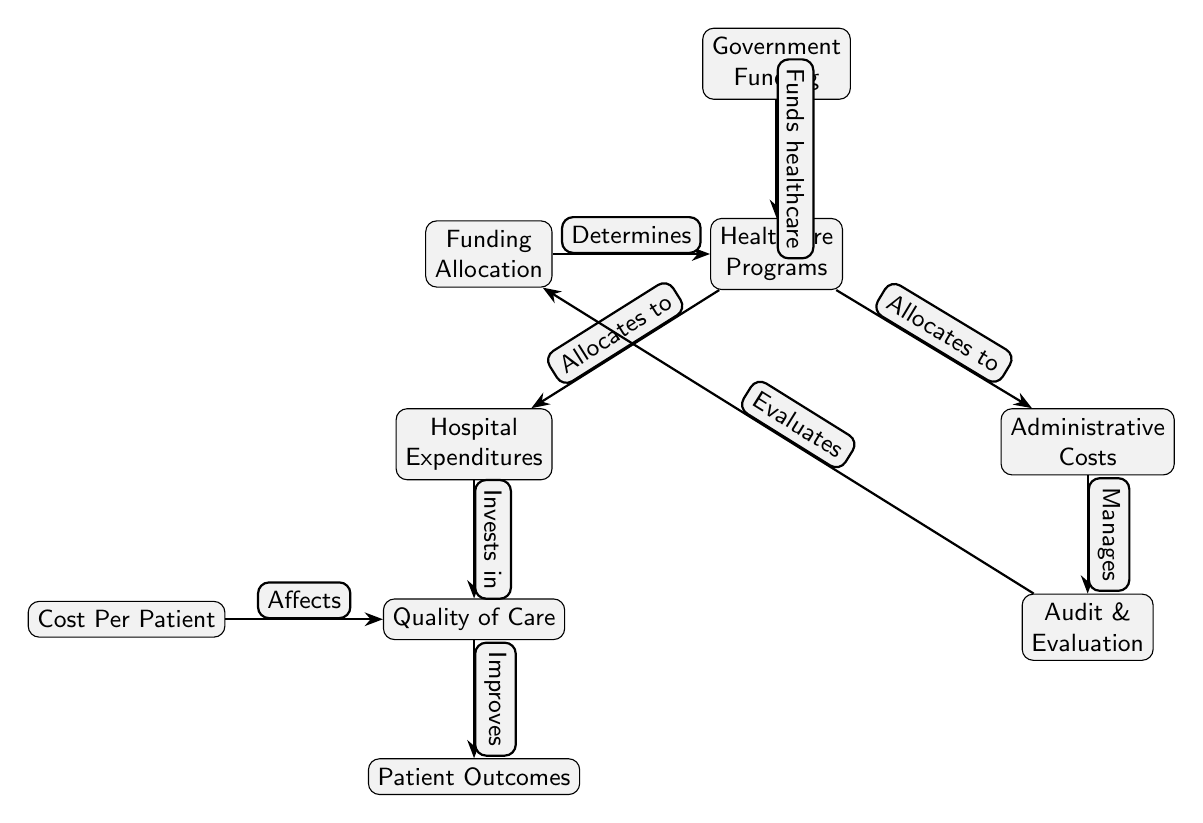What is the first node in the diagram? The first node, positioned at the top of the diagram, is "Government Funding." It serves as the starting point from which healthcare funding flows to various programs.
Answer: Government Funding How many nodes are present in the diagram? To determine the number of nodes, we can count each distinct block in the diagram. There are a total of 8 nodes representing various components of the cost efficiency evaluation.
Answer: 8 What does "Funding Allocation" determine? The "Funding Allocation" node determines the "Healthcare Programs" to which funds are directed. This relationship is indicated by the edge that points from "Funding Allocation" to "Healthcare Programs."
Answer: Healthcare Programs What does the "Audit & Evaluation" node manage? The "Audit & Evaluation" node manages the "Administrative Costs," as shown by the edge that connects these two nodes pointing from "Administrative Costs" to "Audit & Evaluation."
Answer: Administrative Costs What is the relationship between "Quality of Care" and "Patient Outcomes"? The edge between "Quality of Care" and "Patient Outcomes" indicates that improvements in quality lead to better patient outcomes. Therefore, the flow suggests a direct relationship where enhanced quality affects outcomes positively.
Answer: Improves What affects "Quality of Care"? "Cost Per Patient" affects "Quality of Care," as indicated by the edge labeled "Affects" connecting these two nodes. Investing in cost per patient can lead to improvements or decline in the quality experienced.
Answer: Cost Per Patient What does the "Government Funding" node do? The "Government Funding" node funds healthcare, as signified by the labeled edge that connects it to the "Healthcare Programs" node. This clearly outlines its function as a financial source for healthcare initiatives.
Answer: Funds healthcare Which node is evaluated by the "Audit & Evaluation" process? The "Audit & Evaluation" process evaluates the "Funding Allocation," based on the direct edge that originates from "Audit & Evaluation" and points toward "Funding Allocation."
Answer: Funding Allocation How do "Hospital Expenditures" and "Administrative Costs" relate to "Healthcare Programs"? Both "Hospital Expenditures" and "Administrative Costs" receive allocations from "Healthcare Programs," shown by the edges leading from "Healthcare Programs" respectively to these two nodes. They illustrate different aspects of expenditure within healthcare.
Answer: Allocates to 